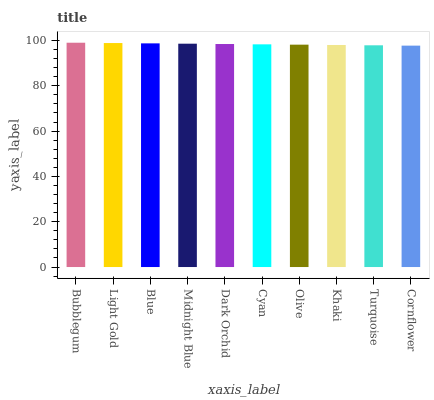Is Light Gold the minimum?
Answer yes or no. No. Is Light Gold the maximum?
Answer yes or no. No. Is Bubblegum greater than Light Gold?
Answer yes or no. Yes. Is Light Gold less than Bubblegum?
Answer yes or no. Yes. Is Light Gold greater than Bubblegum?
Answer yes or no. No. Is Bubblegum less than Light Gold?
Answer yes or no. No. Is Dark Orchid the high median?
Answer yes or no. Yes. Is Cyan the low median?
Answer yes or no. Yes. Is Bubblegum the high median?
Answer yes or no. No. Is Dark Orchid the low median?
Answer yes or no. No. 